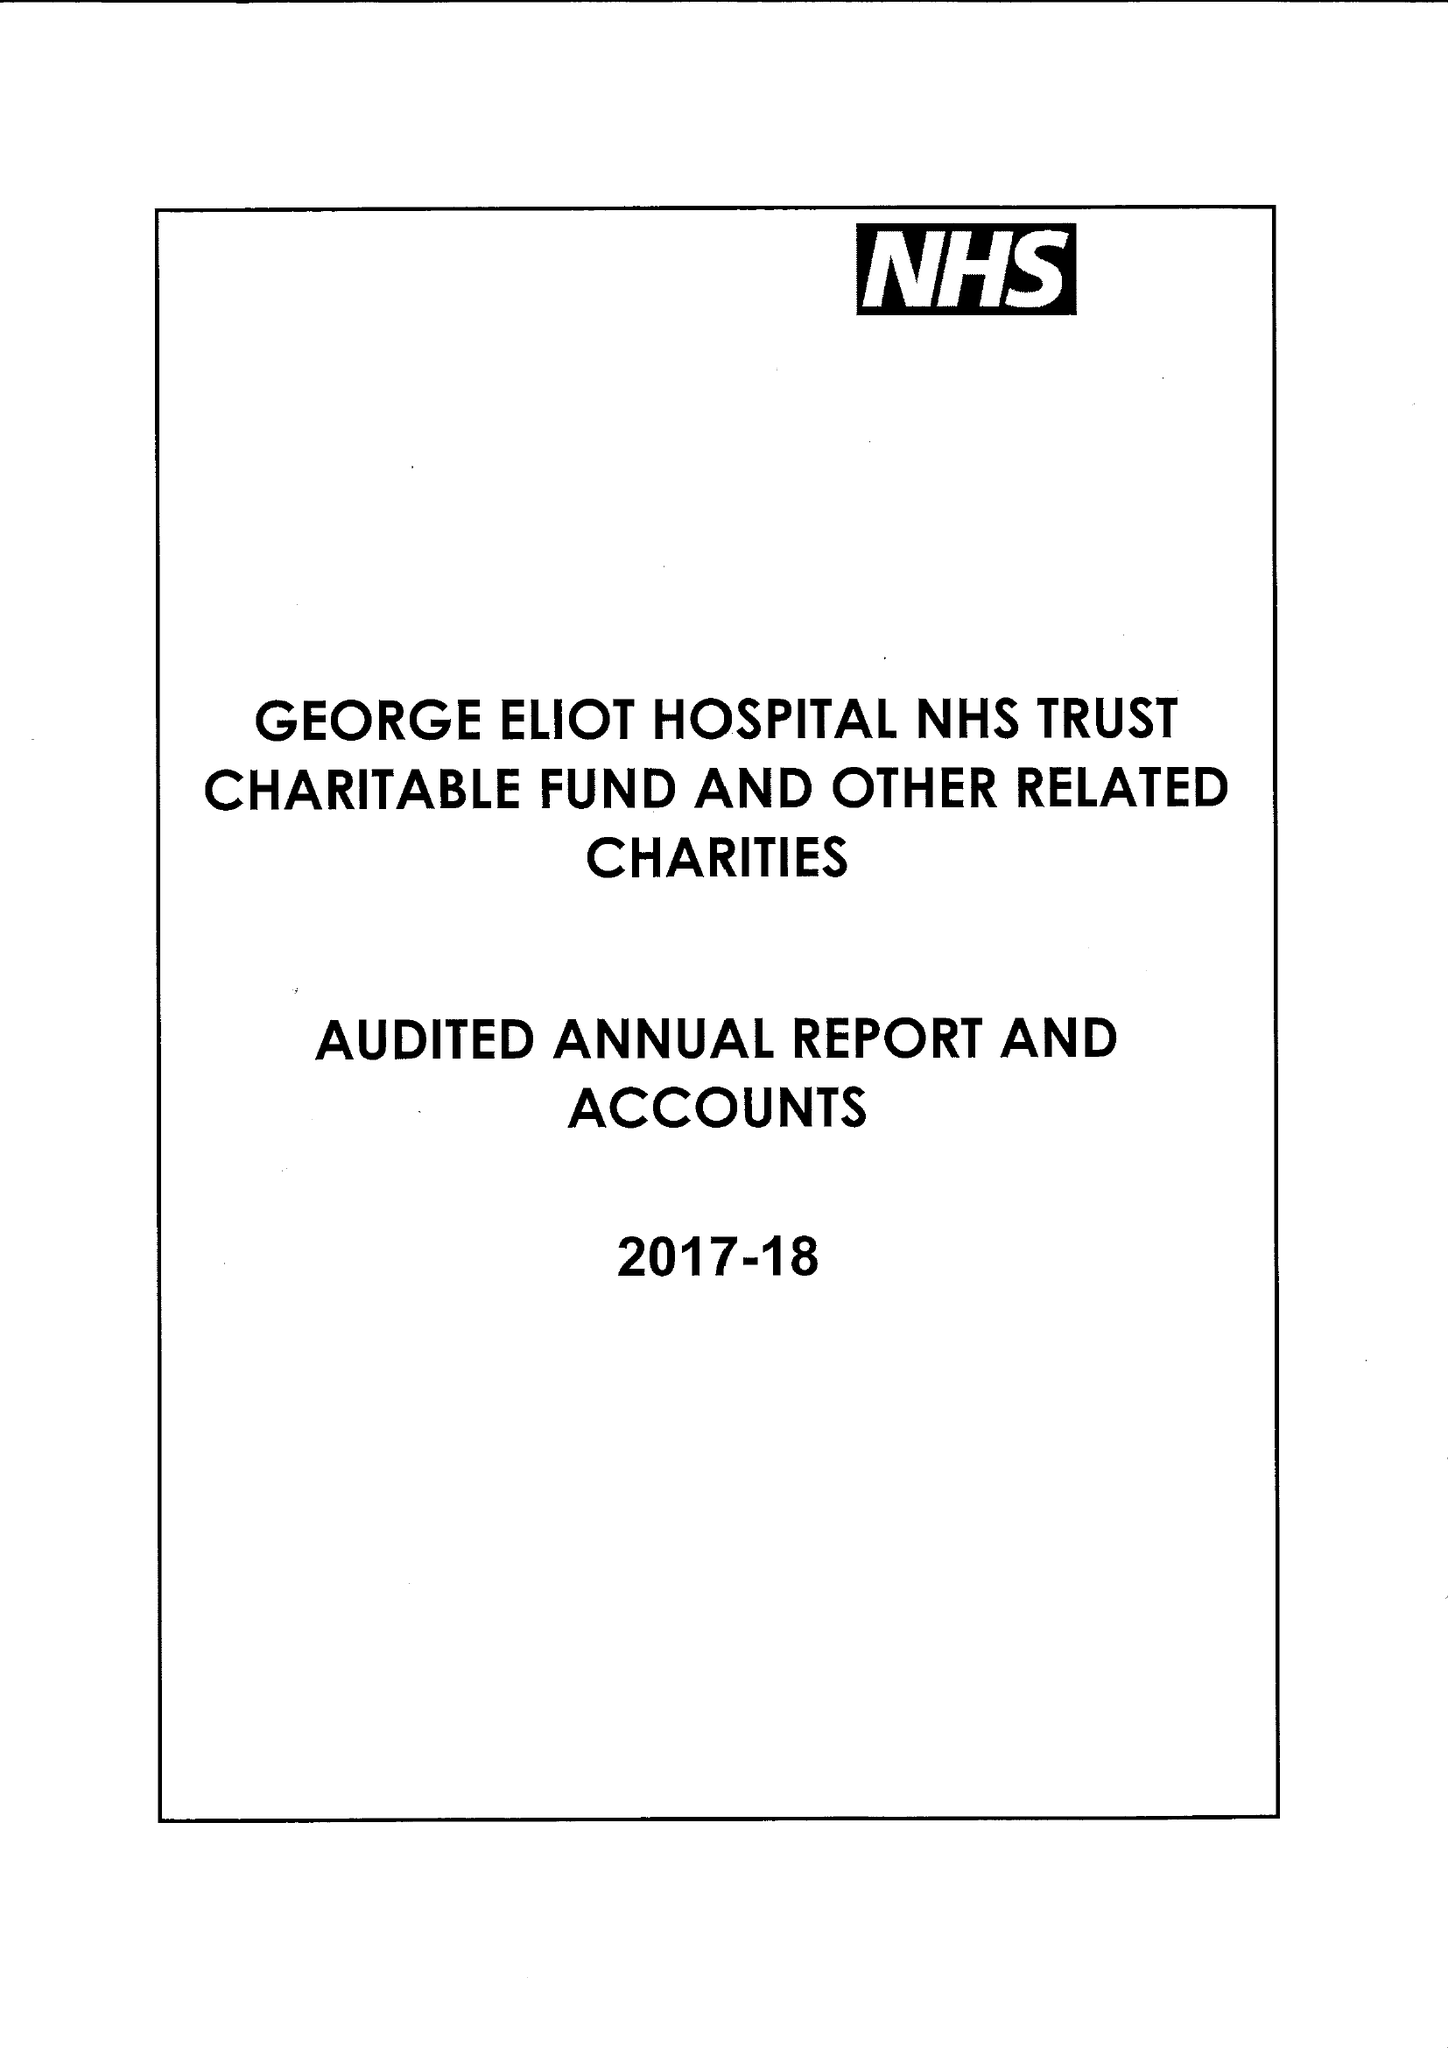What is the value for the address__street_line?
Answer the question using a single word or phrase. COLLEGE STREET 